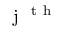Convert formula to latex. <formula><loc_0><loc_0><loc_500><loc_500>j ^ { t h }</formula> 